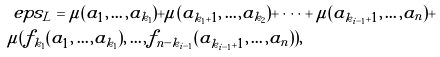Convert formula to latex. <formula><loc_0><loc_0><loc_500><loc_500>& \ e p s _ { L } = \mu ( a _ { 1 } , \dots , a _ { k _ { 1 } } ) + \mu ( a _ { k _ { 1 } + 1 } , \dots , a _ { k _ { 2 } } ) + \dots + \mu ( a _ { k _ { i - 1 } + 1 } , \dots , a _ { n } ) + \\ & \mu ( f _ { k _ { 1 } } ( a _ { 1 } , \dots , a _ { k _ { 1 } } ) , \dots , f _ { n - k _ { i - 1 } } ( a _ { k _ { i - 1 } + 1 } , \dots , a _ { n } ) ) ,</formula> 